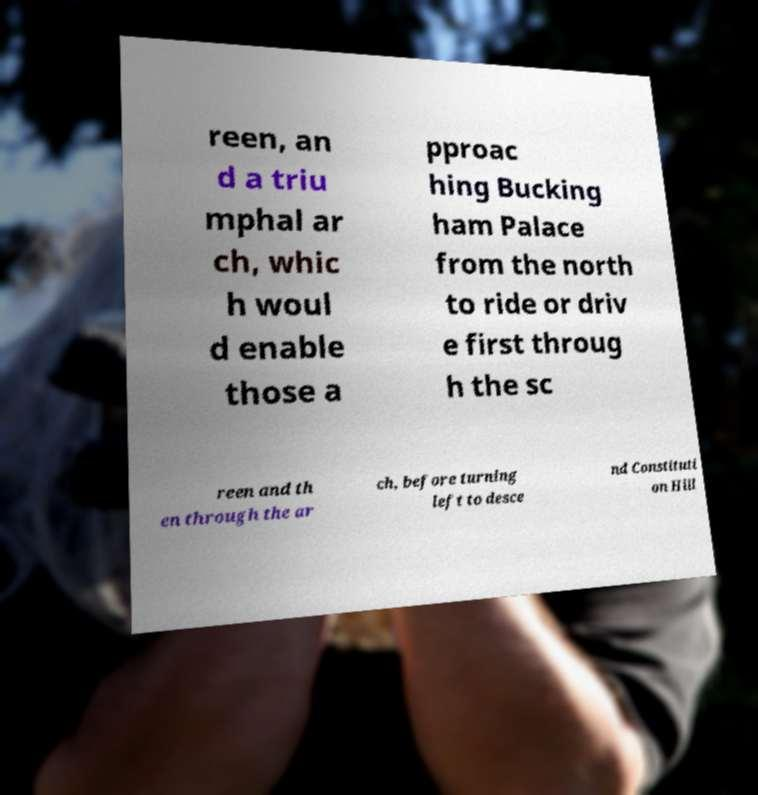Please identify and transcribe the text found in this image. reen, an d a triu mphal ar ch, whic h woul d enable those a pproac hing Bucking ham Palace from the north to ride or driv e first throug h the sc reen and th en through the ar ch, before turning left to desce nd Constituti on Hill 